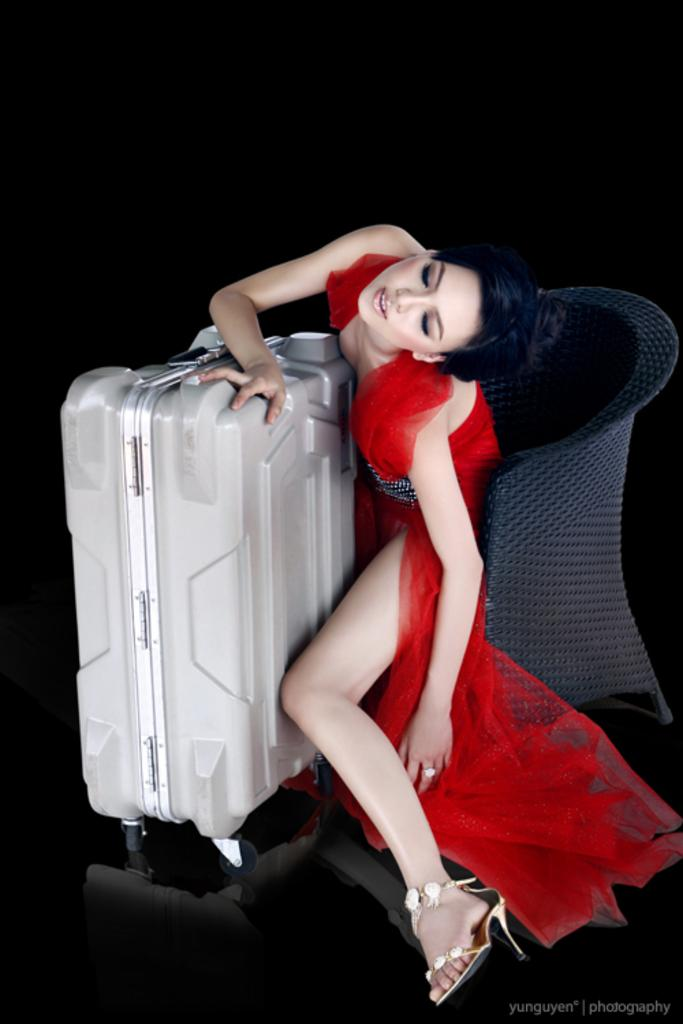What is the main subject of the image? The main subject of the image is a lady sitting in the center. What is the lady holding in the image? The lady is holding a trolley. What type of event is the lady attending in the image? There is no indication of an event in the image; it only shows a lady sitting and holding a trolley. What arithmetic problem is the lady solving in the image? There is no arithmetic problem visible in the image; the lady is simply holding a trolley. 